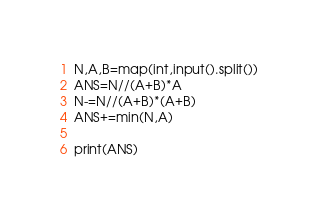<code> <loc_0><loc_0><loc_500><loc_500><_Python_>N,A,B=map(int,input().split())
ANS=N//(A+B)*A
N-=N//(A+B)*(A+B)
ANS+=min(N,A)

print(ANS)</code> 